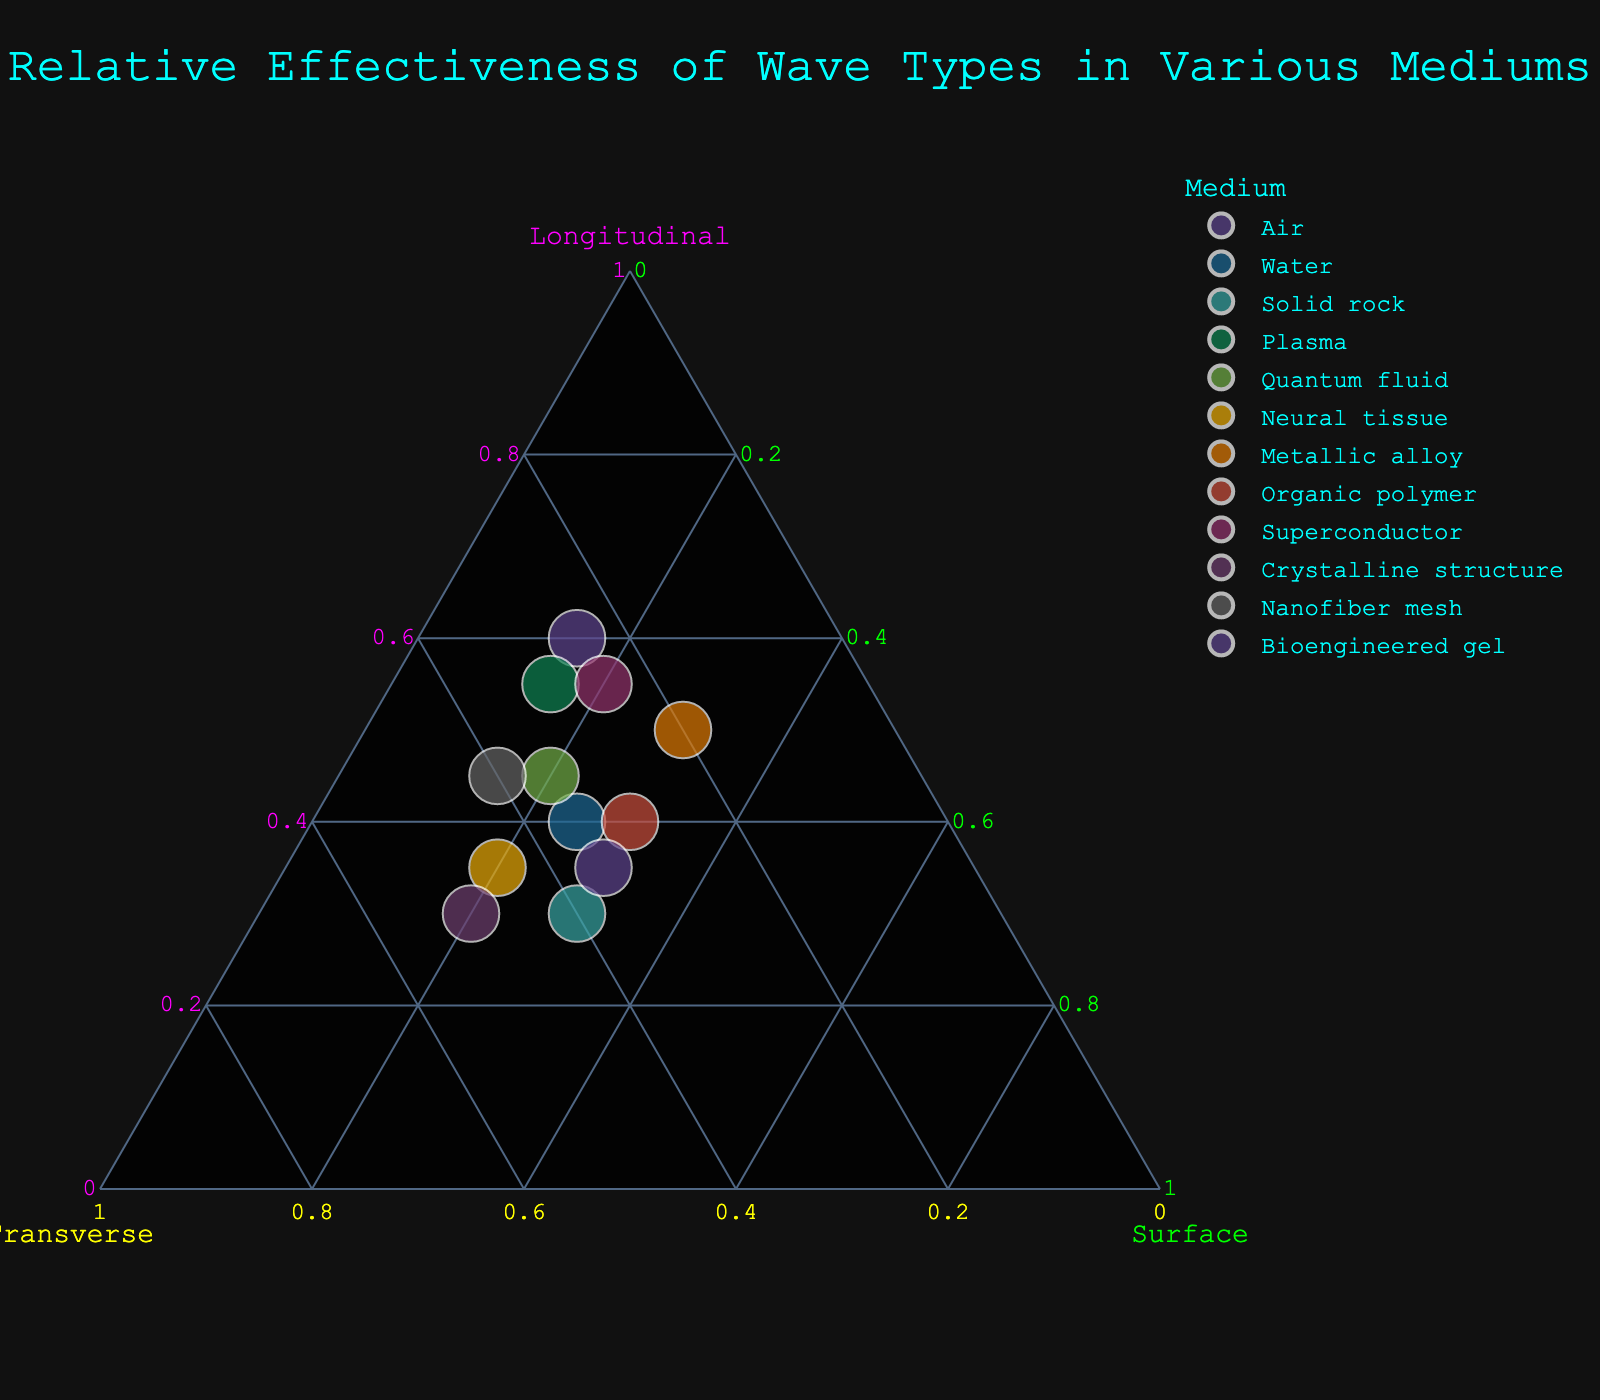What is the title of the plot? The title is usually found at the top of the plot representing the main topic of the figure.
Answer: Relative Effectiveness of Wave Types in Various Mediums Which medium has the highest percentage of longitudinal waves? Look for the point that is positioned the furthest along the longitudinal axis. Each point’s position indicates the wave type percentages.
Answer: Air Which medium has equal percentages of transverse and surface waves? A data point where the values of transverse and surface waves are the same will be equally positioned along both the transverse and surface axes.
Answer: Crystalline structure Which medium has the highest percentage of surface waves? The point furthest along the surface axis will have the highest percentage of surface waves.
Answer: Metallic alloy How does the effectiveness of transverse waves in water compare to that in quantum fluid? Compare the position of the data points for water and quantum fluid along the transverse axis.
Answer: Water has 35% transverse waves, quantum fluid has 35%; they are equal What is the average percentage of longitudinal waves across solid rock, plasma, and crystalline structure? Add the longitudinal percentages of the three mediums and then divide by the number of mediums. (30 + 55 + 30) / 3 = 115 / 3 = 38.33
Answer: 38.33 Which medium has the lowest percentage of transverse waves? The point closest to the longitudinal-surface axis indicates the lowest transverse wave percentage.
Answer: Metallic alloy Are there any mediums where the effectiveness of longitudinal waves is greater than both transverse and surface waves? Identify the points that have the highest value on the longitudinal axis compared to their transverse and surface values. Examples include looking at the relative positions on the plot.
Answer: Air, Plasma, Superconductor Which three mediums have the most balanced distribution among the three types of waves? Look for points that are closest to the center, where all three types are similar in percentage.
Answer: Solid rock, Organic polymer, Bioengineered gel What is the median percentage of transverse waves for all mediums? First, list all transverse wave percentages, then find the median value. Sorted transverse values: 20, 20, 20, 25, 25, 30, 30, 30, 35, 35, 40, 45. The median is the average of the 6th and 7th values: (30 + 30) / 2 = 30
Answer: 30 